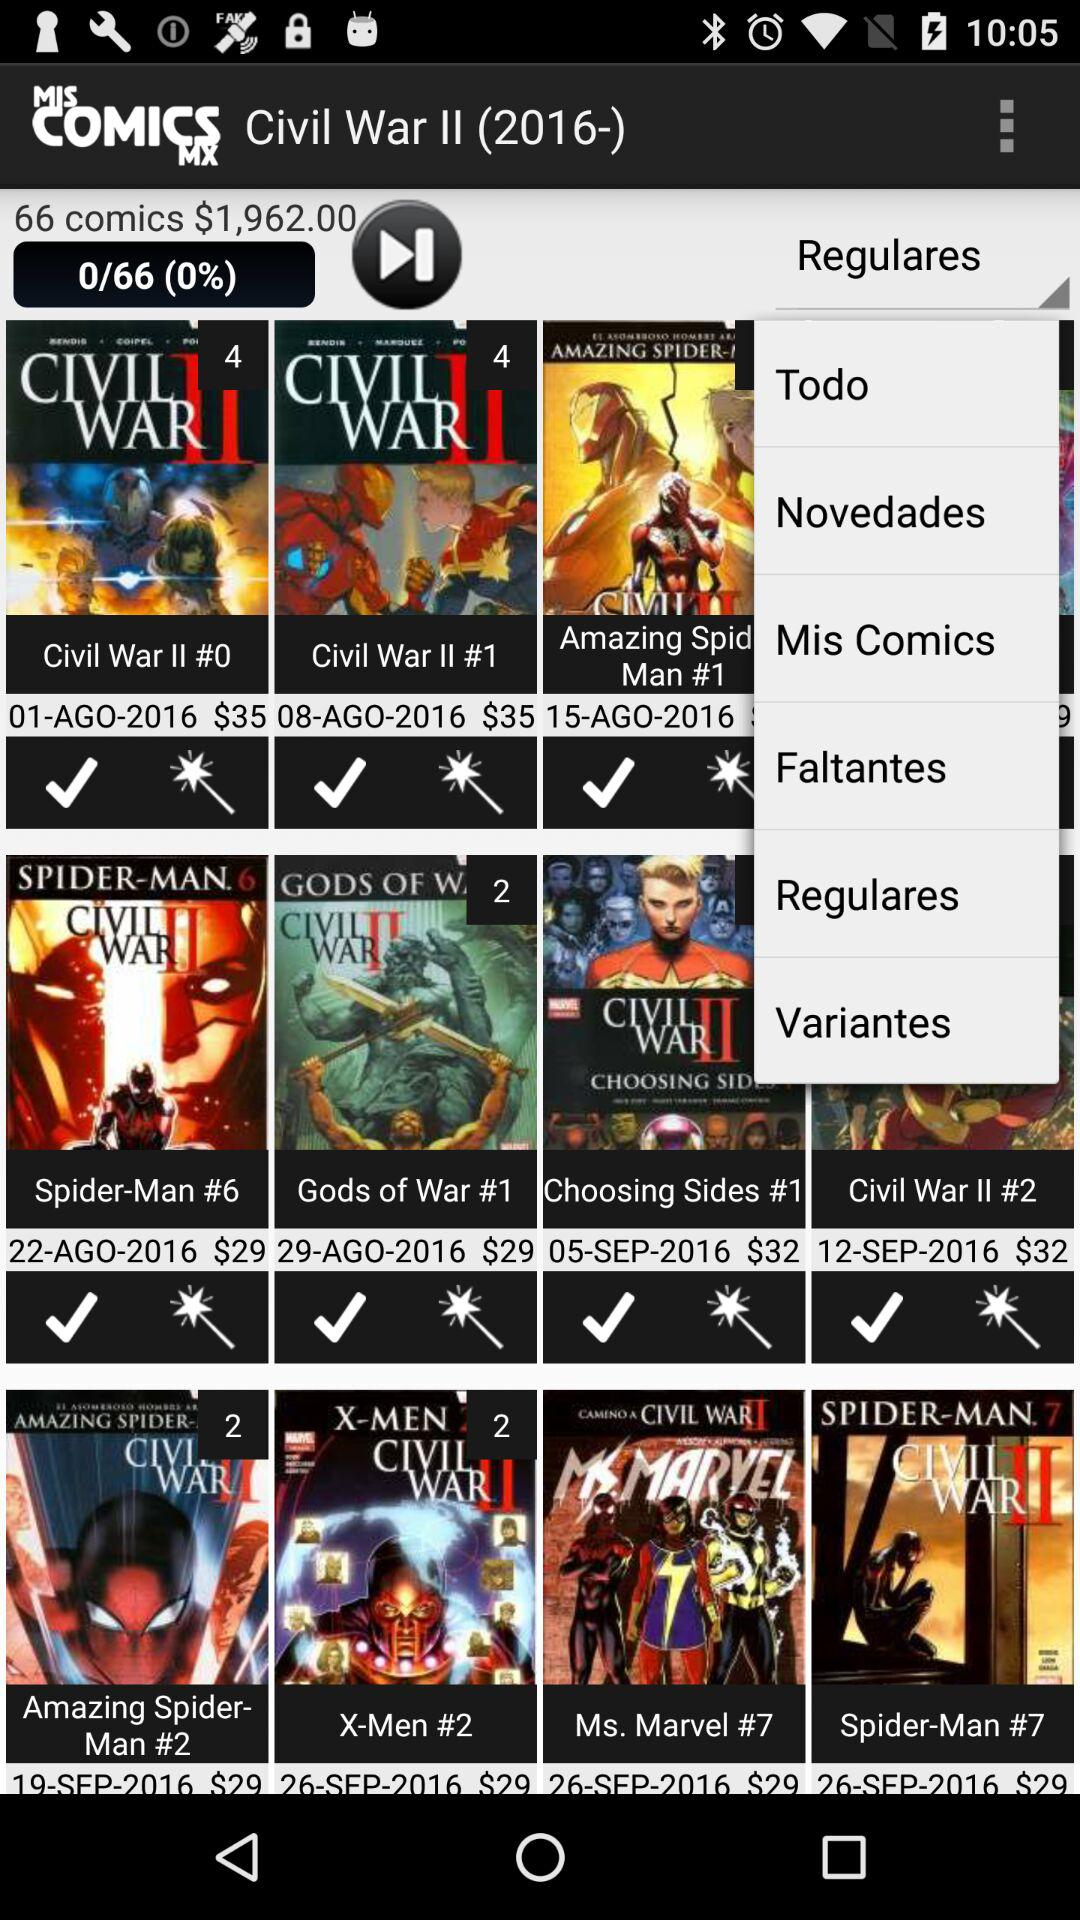What is the total price of the comics? The total price of the comics is $1,962.00. 